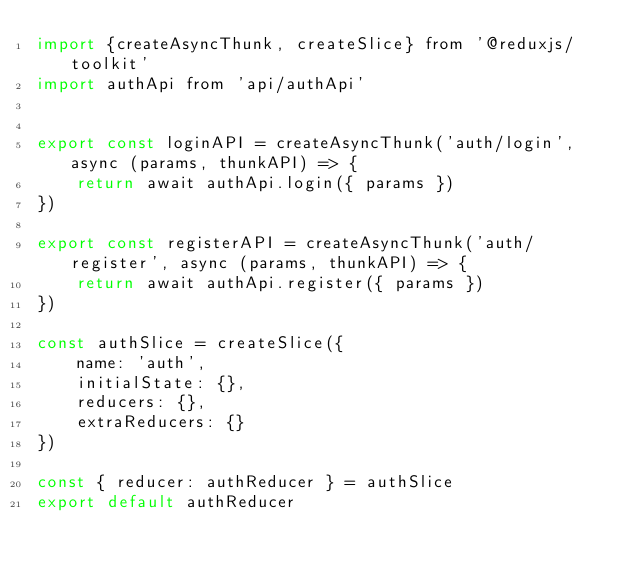<code> <loc_0><loc_0><loc_500><loc_500><_JavaScript_>import {createAsyncThunk, createSlice} from '@reduxjs/toolkit'
import authApi from 'api/authApi'


export const loginAPI = createAsyncThunk('auth/login', async (params, thunkAPI) => {
    return await authApi.login({ params })
})

export const registerAPI = createAsyncThunk('auth/register', async (params, thunkAPI) => {
    return await authApi.register({ params })
})

const authSlice = createSlice({
    name: 'auth',
    initialState: {},
    reducers: {},
    extraReducers: {}
})

const { reducer: authReducer } = authSlice
export default authReducer</code> 